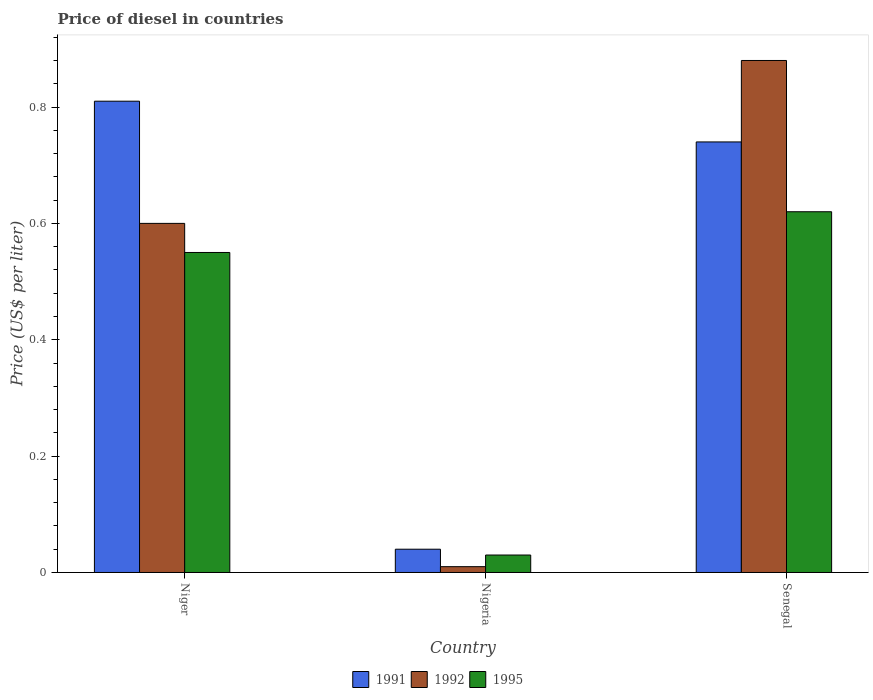Are the number of bars per tick equal to the number of legend labels?
Provide a short and direct response. Yes. Are the number of bars on each tick of the X-axis equal?
Make the answer very short. Yes. How many bars are there on the 3rd tick from the left?
Ensure brevity in your answer.  3. How many bars are there on the 3rd tick from the right?
Your answer should be very brief. 3. What is the label of the 1st group of bars from the left?
Offer a terse response. Niger. What is the price of diesel in 1991 in Senegal?
Your response must be concise. 0.74. Across all countries, what is the maximum price of diesel in 1995?
Offer a very short reply. 0.62. Across all countries, what is the minimum price of diesel in 1991?
Give a very brief answer. 0.04. In which country was the price of diesel in 1995 maximum?
Give a very brief answer. Senegal. In which country was the price of diesel in 1995 minimum?
Your answer should be very brief. Nigeria. What is the total price of diesel in 1992 in the graph?
Offer a very short reply. 1.49. What is the difference between the price of diesel in 1992 in Nigeria and that in Senegal?
Provide a succinct answer. -0.87. What is the difference between the price of diesel in 1992 in Niger and the price of diesel in 1995 in Nigeria?
Ensure brevity in your answer.  0.57. What is the average price of diesel in 1995 per country?
Your answer should be compact. 0.4. What is the difference between the price of diesel of/in 1992 and price of diesel of/in 1991 in Nigeria?
Give a very brief answer. -0.03. In how many countries, is the price of diesel in 1991 greater than 0.04 US$?
Your response must be concise. 2. What is the ratio of the price of diesel in 1992 in Niger to that in Nigeria?
Offer a very short reply. 60. Is the difference between the price of diesel in 1992 in Niger and Nigeria greater than the difference between the price of diesel in 1991 in Niger and Nigeria?
Keep it short and to the point. No. What is the difference between the highest and the second highest price of diesel in 1995?
Provide a short and direct response. 0.07. What is the difference between the highest and the lowest price of diesel in 1992?
Provide a short and direct response. 0.87. In how many countries, is the price of diesel in 1995 greater than the average price of diesel in 1995 taken over all countries?
Your response must be concise. 2. What does the 3rd bar from the right in Senegal represents?
Your answer should be compact. 1991. How many countries are there in the graph?
Your response must be concise. 3. Does the graph contain grids?
Offer a very short reply. No. What is the title of the graph?
Provide a short and direct response. Price of diesel in countries. Does "1990" appear as one of the legend labels in the graph?
Your answer should be very brief. No. What is the label or title of the Y-axis?
Your answer should be compact. Price (US$ per liter). What is the Price (US$ per liter) of 1991 in Niger?
Provide a succinct answer. 0.81. What is the Price (US$ per liter) in 1995 in Niger?
Give a very brief answer. 0.55. What is the Price (US$ per liter) of 1991 in Nigeria?
Provide a short and direct response. 0.04. What is the Price (US$ per liter) in 1992 in Nigeria?
Your answer should be very brief. 0.01. What is the Price (US$ per liter) in 1995 in Nigeria?
Give a very brief answer. 0.03. What is the Price (US$ per liter) in 1991 in Senegal?
Provide a succinct answer. 0.74. What is the Price (US$ per liter) of 1995 in Senegal?
Offer a very short reply. 0.62. Across all countries, what is the maximum Price (US$ per liter) of 1991?
Ensure brevity in your answer.  0.81. Across all countries, what is the maximum Price (US$ per liter) in 1995?
Keep it short and to the point. 0.62. Across all countries, what is the minimum Price (US$ per liter) of 1992?
Your answer should be very brief. 0.01. What is the total Price (US$ per liter) of 1991 in the graph?
Ensure brevity in your answer.  1.59. What is the total Price (US$ per liter) in 1992 in the graph?
Your response must be concise. 1.49. What is the difference between the Price (US$ per liter) of 1991 in Niger and that in Nigeria?
Your answer should be compact. 0.77. What is the difference between the Price (US$ per liter) in 1992 in Niger and that in Nigeria?
Offer a very short reply. 0.59. What is the difference between the Price (US$ per liter) in 1995 in Niger and that in Nigeria?
Your answer should be very brief. 0.52. What is the difference between the Price (US$ per liter) of 1991 in Niger and that in Senegal?
Keep it short and to the point. 0.07. What is the difference between the Price (US$ per liter) of 1992 in Niger and that in Senegal?
Offer a very short reply. -0.28. What is the difference between the Price (US$ per liter) of 1995 in Niger and that in Senegal?
Your answer should be very brief. -0.07. What is the difference between the Price (US$ per liter) of 1992 in Nigeria and that in Senegal?
Offer a terse response. -0.87. What is the difference between the Price (US$ per liter) in 1995 in Nigeria and that in Senegal?
Your answer should be compact. -0.59. What is the difference between the Price (US$ per liter) in 1991 in Niger and the Price (US$ per liter) in 1992 in Nigeria?
Ensure brevity in your answer.  0.8. What is the difference between the Price (US$ per liter) in 1991 in Niger and the Price (US$ per liter) in 1995 in Nigeria?
Provide a succinct answer. 0.78. What is the difference between the Price (US$ per liter) of 1992 in Niger and the Price (US$ per liter) of 1995 in Nigeria?
Ensure brevity in your answer.  0.57. What is the difference between the Price (US$ per liter) in 1991 in Niger and the Price (US$ per liter) in 1992 in Senegal?
Ensure brevity in your answer.  -0.07. What is the difference between the Price (US$ per liter) of 1991 in Niger and the Price (US$ per liter) of 1995 in Senegal?
Offer a very short reply. 0.19. What is the difference between the Price (US$ per liter) in 1992 in Niger and the Price (US$ per liter) in 1995 in Senegal?
Make the answer very short. -0.02. What is the difference between the Price (US$ per liter) of 1991 in Nigeria and the Price (US$ per liter) of 1992 in Senegal?
Provide a succinct answer. -0.84. What is the difference between the Price (US$ per liter) in 1991 in Nigeria and the Price (US$ per liter) in 1995 in Senegal?
Your answer should be very brief. -0.58. What is the difference between the Price (US$ per liter) in 1992 in Nigeria and the Price (US$ per liter) in 1995 in Senegal?
Offer a terse response. -0.61. What is the average Price (US$ per liter) in 1991 per country?
Provide a succinct answer. 0.53. What is the average Price (US$ per liter) in 1992 per country?
Your answer should be very brief. 0.5. What is the difference between the Price (US$ per liter) in 1991 and Price (US$ per liter) in 1992 in Niger?
Offer a very short reply. 0.21. What is the difference between the Price (US$ per liter) in 1991 and Price (US$ per liter) in 1995 in Niger?
Your answer should be compact. 0.26. What is the difference between the Price (US$ per liter) in 1991 and Price (US$ per liter) in 1992 in Nigeria?
Your answer should be compact. 0.03. What is the difference between the Price (US$ per liter) of 1992 and Price (US$ per liter) of 1995 in Nigeria?
Keep it short and to the point. -0.02. What is the difference between the Price (US$ per liter) of 1991 and Price (US$ per liter) of 1992 in Senegal?
Provide a short and direct response. -0.14. What is the difference between the Price (US$ per liter) of 1991 and Price (US$ per liter) of 1995 in Senegal?
Offer a terse response. 0.12. What is the difference between the Price (US$ per liter) in 1992 and Price (US$ per liter) in 1995 in Senegal?
Ensure brevity in your answer.  0.26. What is the ratio of the Price (US$ per liter) of 1991 in Niger to that in Nigeria?
Your answer should be very brief. 20.25. What is the ratio of the Price (US$ per liter) of 1992 in Niger to that in Nigeria?
Ensure brevity in your answer.  60. What is the ratio of the Price (US$ per liter) of 1995 in Niger to that in Nigeria?
Offer a very short reply. 18.33. What is the ratio of the Price (US$ per liter) in 1991 in Niger to that in Senegal?
Provide a succinct answer. 1.09. What is the ratio of the Price (US$ per liter) of 1992 in Niger to that in Senegal?
Provide a short and direct response. 0.68. What is the ratio of the Price (US$ per liter) in 1995 in Niger to that in Senegal?
Offer a terse response. 0.89. What is the ratio of the Price (US$ per liter) of 1991 in Nigeria to that in Senegal?
Ensure brevity in your answer.  0.05. What is the ratio of the Price (US$ per liter) in 1992 in Nigeria to that in Senegal?
Your response must be concise. 0.01. What is the ratio of the Price (US$ per liter) in 1995 in Nigeria to that in Senegal?
Your answer should be very brief. 0.05. What is the difference between the highest and the second highest Price (US$ per liter) of 1991?
Offer a very short reply. 0.07. What is the difference between the highest and the second highest Price (US$ per liter) in 1992?
Keep it short and to the point. 0.28. What is the difference between the highest and the second highest Price (US$ per liter) of 1995?
Offer a terse response. 0.07. What is the difference between the highest and the lowest Price (US$ per liter) in 1991?
Ensure brevity in your answer.  0.77. What is the difference between the highest and the lowest Price (US$ per liter) of 1992?
Offer a very short reply. 0.87. What is the difference between the highest and the lowest Price (US$ per liter) in 1995?
Ensure brevity in your answer.  0.59. 